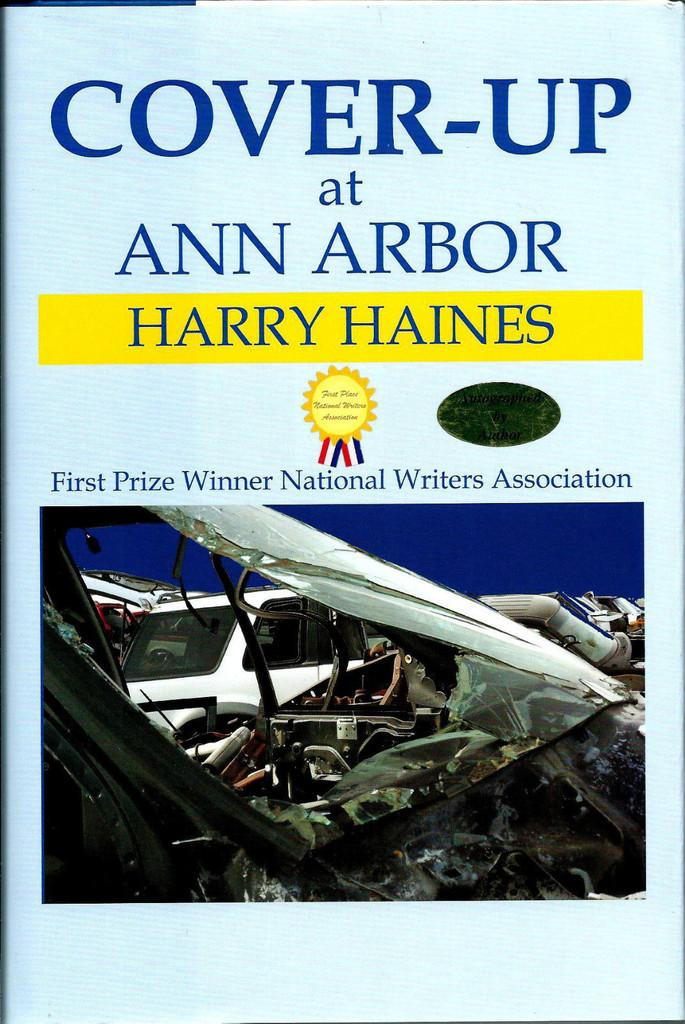Provide a one-sentence caption for the provided image. Book cover of a book by Harry Haines. 